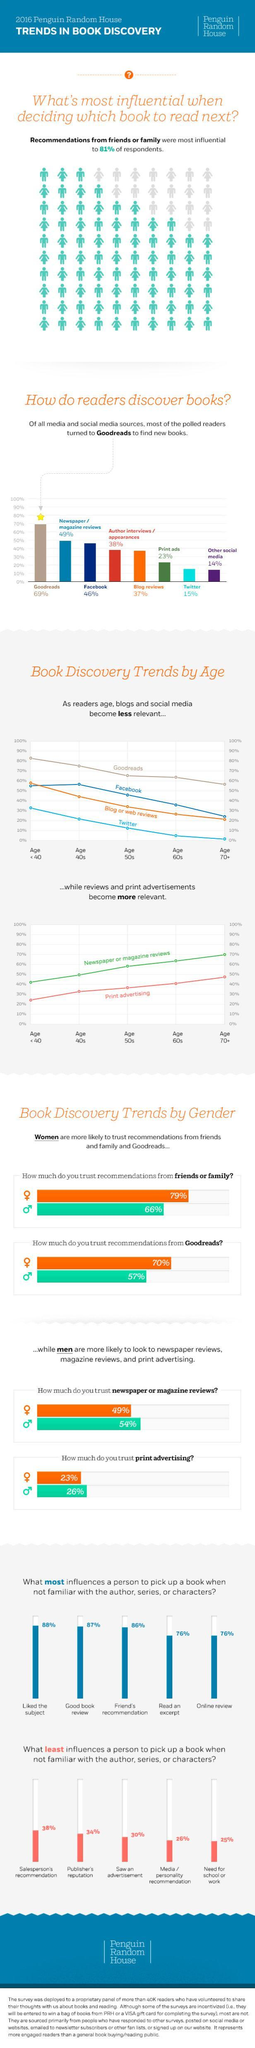What percentage of "Read an excerpt" and "Liked the subject" together influences a person to pick up a book?
Answer the question with a short phrase. 164% What percentage of "online reviews" and "good book reviews" together influences a person to pick up a book? 163% Which factor has the least influence on a person to pick up a book? Need for school or work Which two factors have the same influence on a person to pick up a book? Read an excerpt, Online review What percentage of respondents are not influenced by the recommendation of friends and family in deciding which book to read next? 19% What percentage of readers discover books through Twitter and print ads together? 38% What percentage of readers discover books through Facebook and Blog reviews together? 83% 